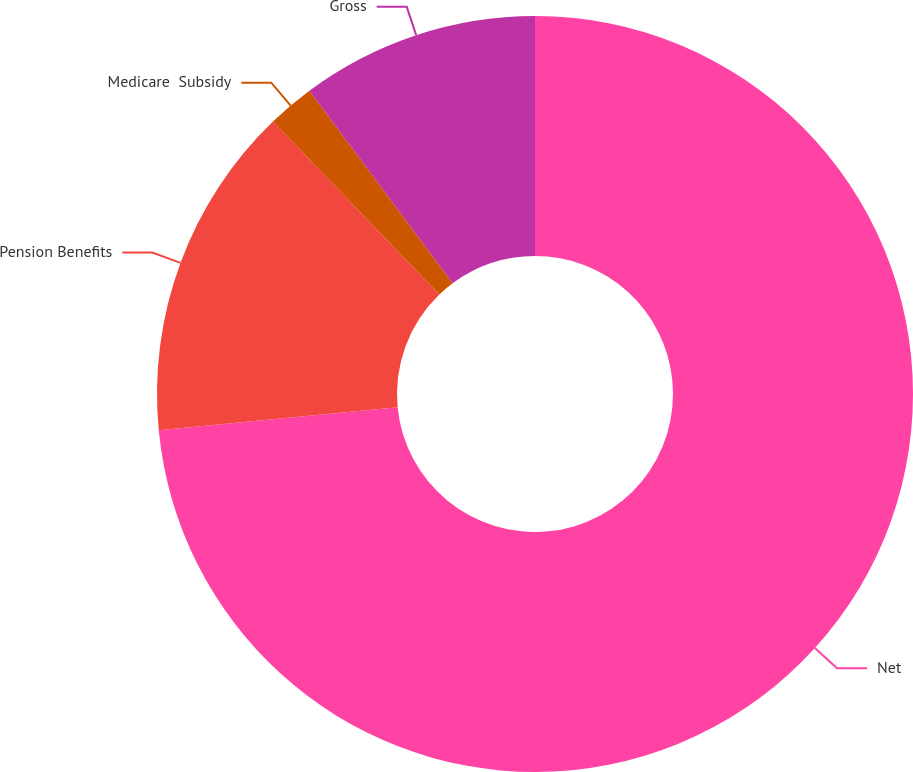Convert chart. <chart><loc_0><loc_0><loc_500><loc_500><pie_chart><fcel>Net<fcel>Pension Benefits<fcel>Medicare  Subsidy<fcel>Gross<nl><fcel>73.46%<fcel>14.34%<fcel>2.01%<fcel>10.18%<nl></chart> 